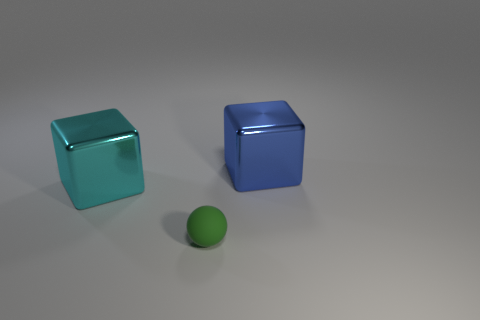Add 2 small yellow cylinders. How many objects exist? 5 Subtract all blocks. How many objects are left? 1 Subtract all cyan blocks. Subtract all metal objects. How many objects are left? 0 Add 1 large cyan metal objects. How many large cyan metal objects are left? 2 Add 3 big cyan shiny cubes. How many big cyan shiny cubes exist? 4 Subtract 0 green blocks. How many objects are left? 3 